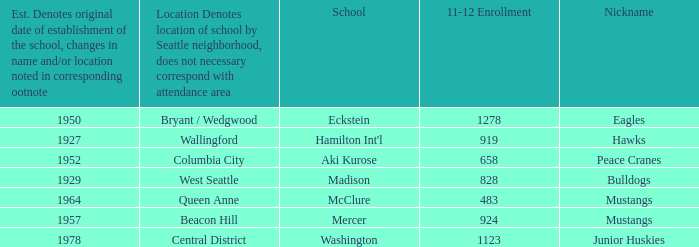Name the location for school eckstein Bryant / Wedgwood. 